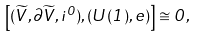Convert formula to latex. <formula><loc_0><loc_0><loc_500><loc_500>\left [ ( \widetilde { V } , \partial \widetilde { V } , i ^ { 0 } ) , ( U ( 1 ) , e ) \right ] \cong 0 ,</formula> 